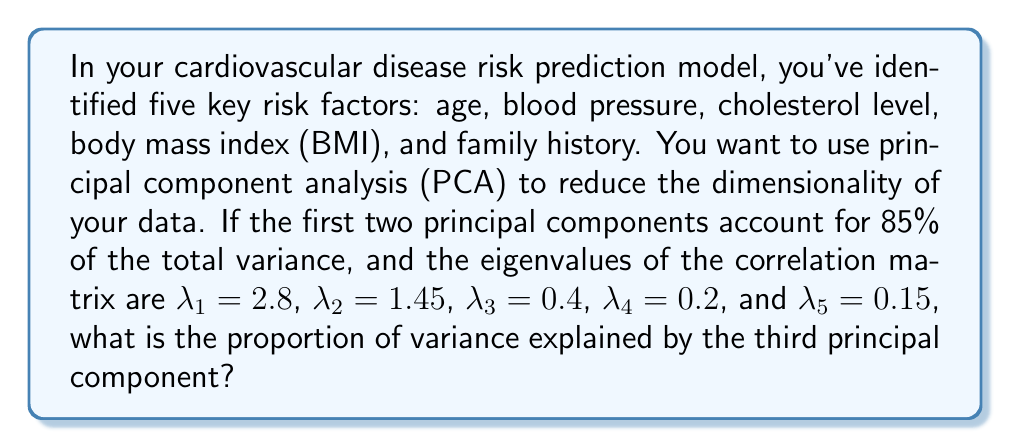Teach me how to tackle this problem. To solve this problem, we'll follow these steps:

1) First, recall that in PCA, the eigenvalues represent the amount of variance explained by each principal component.

2) The total variance in a PCA is equal to the sum of all eigenvalues. Let's calculate this:

   $$\text{Total Variance} = \sum_{i=1}^5 \lambda_i = 2.8 + 1.45 + 0.4 + 0.2 + 0.15 = 5$$

3) The proportion of variance explained by each component is its eigenvalue divided by the total variance. For the third component:

   $$\text{Proportion of Variance}_3 = \frac{\lambda_3}{\text{Total Variance}} = \frac{0.4}{5} = 0.08$$

4) We can verify this by calculating the proportion of variance explained by the first two components:

   $$\text{Proportion of Variance}_{1,2} = \frac{\lambda_1 + \lambda_2}{\text{Total Variance}} = \frac{2.8 + 1.45}{5} = 0.85$$

   This matches the given information that the first two components account for 85% of the total variance.

5) Therefore, the third principal component explains 8% of the total variance in the dataset.
Answer: 0.08 or 8% 